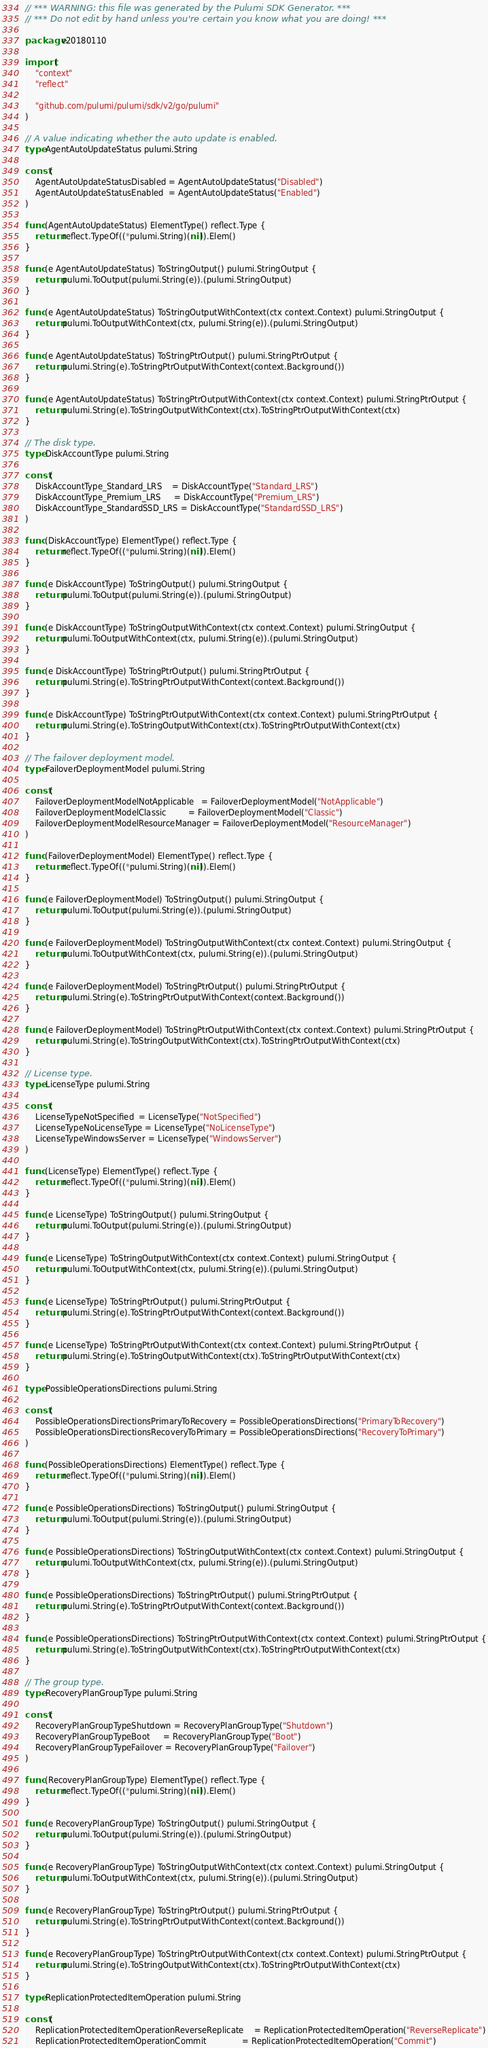<code> <loc_0><loc_0><loc_500><loc_500><_Go_>// *** WARNING: this file was generated by the Pulumi SDK Generator. ***
// *** Do not edit by hand unless you're certain you know what you are doing! ***

package v20180110

import (
	"context"
	"reflect"

	"github.com/pulumi/pulumi/sdk/v2/go/pulumi"
)

// A value indicating whether the auto update is enabled.
type AgentAutoUpdateStatus pulumi.String

const (
	AgentAutoUpdateStatusDisabled = AgentAutoUpdateStatus("Disabled")
	AgentAutoUpdateStatusEnabled  = AgentAutoUpdateStatus("Enabled")
)

func (AgentAutoUpdateStatus) ElementType() reflect.Type {
	return reflect.TypeOf((*pulumi.String)(nil)).Elem()
}

func (e AgentAutoUpdateStatus) ToStringOutput() pulumi.StringOutput {
	return pulumi.ToOutput(pulumi.String(e)).(pulumi.StringOutput)
}

func (e AgentAutoUpdateStatus) ToStringOutputWithContext(ctx context.Context) pulumi.StringOutput {
	return pulumi.ToOutputWithContext(ctx, pulumi.String(e)).(pulumi.StringOutput)
}

func (e AgentAutoUpdateStatus) ToStringPtrOutput() pulumi.StringPtrOutput {
	return pulumi.String(e).ToStringPtrOutputWithContext(context.Background())
}

func (e AgentAutoUpdateStatus) ToStringPtrOutputWithContext(ctx context.Context) pulumi.StringPtrOutput {
	return pulumi.String(e).ToStringOutputWithContext(ctx).ToStringPtrOutputWithContext(ctx)
}

// The disk type.
type DiskAccountType pulumi.String

const (
	DiskAccountType_Standard_LRS    = DiskAccountType("Standard_LRS")
	DiskAccountType_Premium_LRS     = DiskAccountType("Premium_LRS")
	DiskAccountType_StandardSSD_LRS = DiskAccountType("StandardSSD_LRS")
)

func (DiskAccountType) ElementType() reflect.Type {
	return reflect.TypeOf((*pulumi.String)(nil)).Elem()
}

func (e DiskAccountType) ToStringOutput() pulumi.StringOutput {
	return pulumi.ToOutput(pulumi.String(e)).(pulumi.StringOutput)
}

func (e DiskAccountType) ToStringOutputWithContext(ctx context.Context) pulumi.StringOutput {
	return pulumi.ToOutputWithContext(ctx, pulumi.String(e)).(pulumi.StringOutput)
}

func (e DiskAccountType) ToStringPtrOutput() pulumi.StringPtrOutput {
	return pulumi.String(e).ToStringPtrOutputWithContext(context.Background())
}

func (e DiskAccountType) ToStringPtrOutputWithContext(ctx context.Context) pulumi.StringPtrOutput {
	return pulumi.String(e).ToStringOutputWithContext(ctx).ToStringPtrOutputWithContext(ctx)
}

// The failover deployment model.
type FailoverDeploymentModel pulumi.String

const (
	FailoverDeploymentModelNotApplicable   = FailoverDeploymentModel("NotApplicable")
	FailoverDeploymentModelClassic         = FailoverDeploymentModel("Classic")
	FailoverDeploymentModelResourceManager = FailoverDeploymentModel("ResourceManager")
)

func (FailoverDeploymentModel) ElementType() reflect.Type {
	return reflect.TypeOf((*pulumi.String)(nil)).Elem()
}

func (e FailoverDeploymentModel) ToStringOutput() pulumi.StringOutput {
	return pulumi.ToOutput(pulumi.String(e)).(pulumi.StringOutput)
}

func (e FailoverDeploymentModel) ToStringOutputWithContext(ctx context.Context) pulumi.StringOutput {
	return pulumi.ToOutputWithContext(ctx, pulumi.String(e)).(pulumi.StringOutput)
}

func (e FailoverDeploymentModel) ToStringPtrOutput() pulumi.StringPtrOutput {
	return pulumi.String(e).ToStringPtrOutputWithContext(context.Background())
}

func (e FailoverDeploymentModel) ToStringPtrOutputWithContext(ctx context.Context) pulumi.StringPtrOutput {
	return pulumi.String(e).ToStringOutputWithContext(ctx).ToStringPtrOutputWithContext(ctx)
}

// License type.
type LicenseType pulumi.String

const (
	LicenseTypeNotSpecified  = LicenseType("NotSpecified")
	LicenseTypeNoLicenseType = LicenseType("NoLicenseType")
	LicenseTypeWindowsServer = LicenseType("WindowsServer")
)

func (LicenseType) ElementType() reflect.Type {
	return reflect.TypeOf((*pulumi.String)(nil)).Elem()
}

func (e LicenseType) ToStringOutput() pulumi.StringOutput {
	return pulumi.ToOutput(pulumi.String(e)).(pulumi.StringOutput)
}

func (e LicenseType) ToStringOutputWithContext(ctx context.Context) pulumi.StringOutput {
	return pulumi.ToOutputWithContext(ctx, pulumi.String(e)).(pulumi.StringOutput)
}

func (e LicenseType) ToStringPtrOutput() pulumi.StringPtrOutput {
	return pulumi.String(e).ToStringPtrOutputWithContext(context.Background())
}

func (e LicenseType) ToStringPtrOutputWithContext(ctx context.Context) pulumi.StringPtrOutput {
	return pulumi.String(e).ToStringOutputWithContext(ctx).ToStringPtrOutputWithContext(ctx)
}

type PossibleOperationsDirections pulumi.String

const (
	PossibleOperationsDirectionsPrimaryToRecovery = PossibleOperationsDirections("PrimaryToRecovery")
	PossibleOperationsDirectionsRecoveryToPrimary = PossibleOperationsDirections("RecoveryToPrimary")
)

func (PossibleOperationsDirections) ElementType() reflect.Type {
	return reflect.TypeOf((*pulumi.String)(nil)).Elem()
}

func (e PossibleOperationsDirections) ToStringOutput() pulumi.StringOutput {
	return pulumi.ToOutput(pulumi.String(e)).(pulumi.StringOutput)
}

func (e PossibleOperationsDirections) ToStringOutputWithContext(ctx context.Context) pulumi.StringOutput {
	return pulumi.ToOutputWithContext(ctx, pulumi.String(e)).(pulumi.StringOutput)
}

func (e PossibleOperationsDirections) ToStringPtrOutput() pulumi.StringPtrOutput {
	return pulumi.String(e).ToStringPtrOutputWithContext(context.Background())
}

func (e PossibleOperationsDirections) ToStringPtrOutputWithContext(ctx context.Context) pulumi.StringPtrOutput {
	return pulumi.String(e).ToStringOutputWithContext(ctx).ToStringPtrOutputWithContext(ctx)
}

// The group type.
type RecoveryPlanGroupType pulumi.String

const (
	RecoveryPlanGroupTypeShutdown = RecoveryPlanGroupType("Shutdown")
	RecoveryPlanGroupTypeBoot     = RecoveryPlanGroupType("Boot")
	RecoveryPlanGroupTypeFailover = RecoveryPlanGroupType("Failover")
)

func (RecoveryPlanGroupType) ElementType() reflect.Type {
	return reflect.TypeOf((*pulumi.String)(nil)).Elem()
}

func (e RecoveryPlanGroupType) ToStringOutput() pulumi.StringOutput {
	return pulumi.ToOutput(pulumi.String(e)).(pulumi.StringOutput)
}

func (e RecoveryPlanGroupType) ToStringOutputWithContext(ctx context.Context) pulumi.StringOutput {
	return pulumi.ToOutputWithContext(ctx, pulumi.String(e)).(pulumi.StringOutput)
}

func (e RecoveryPlanGroupType) ToStringPtrOutput() pulumi.StringPtrOutput {
	return pulumi.String(e).ToStringPtrOutputWithContext(context.Background())
}

func (e RecoveryPlanGroupType) ToStringPtrOutputWithContext(ctx context.Context) pulumi.StringPtrOutput {
	return pulumi.String(e).ToStringOutputWithContext(ctx).ToStringPtrOutputWithContext(ctx)
}

type ReplicationProtectedItemOperation pulumi.String

const (
	ReplicationProtectedItemOperationReverseReplicate    = ReplicationProtectedItemOperation("ReverseReplicate")
	ReplicationProtectedItemOperationCommit              = ReplicationProtectedItemOperation("Commit")</code> 